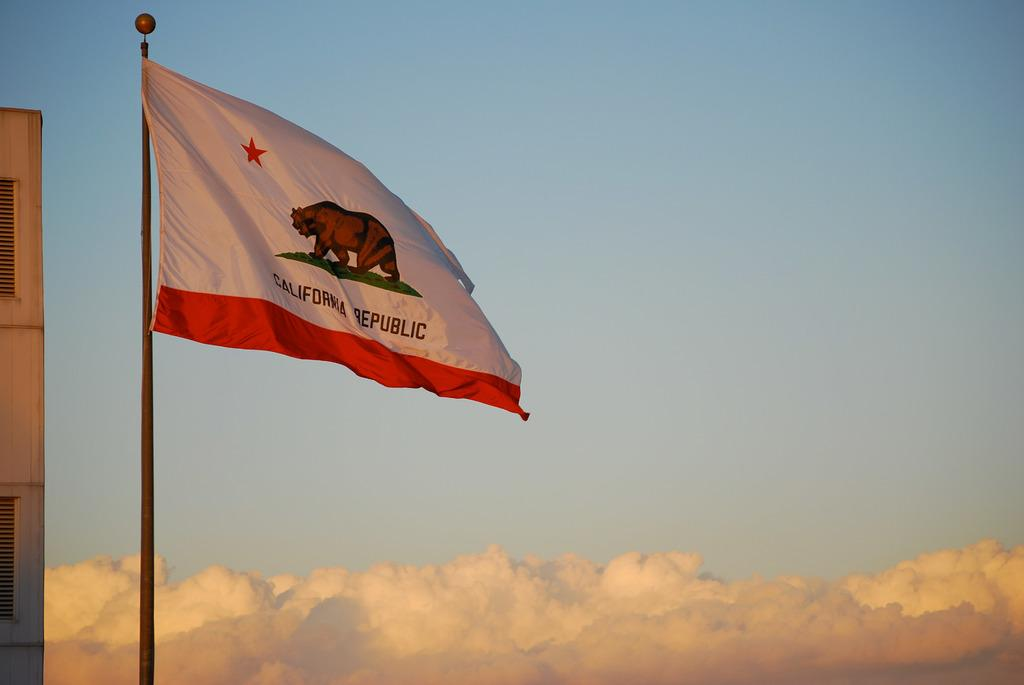What is located on the left side of the image? There is a flag on the left side of the image. What symbol can be seen on the flag? The flag has a bear symbol on it. What is visible on the right side of the image? There is a sky visible on the right side of the image. What type of zinc is being mined in the image? There is no indication of zinc mining in the image; it features a flag with a bear symbol. How many ears of corn can be seen in the image? There are no ears of corn present in the image. 